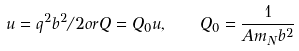<formula> <loc_0><loc_0><loc_500><loc_500>u = q ^ { 2 } b ^ { 2 } / 2 o r Q = Q _ { 0 } u , \quad Q _ { 0 } = \frac { 1 } { A m _ { N } b ^ { 2 } }</formula> 